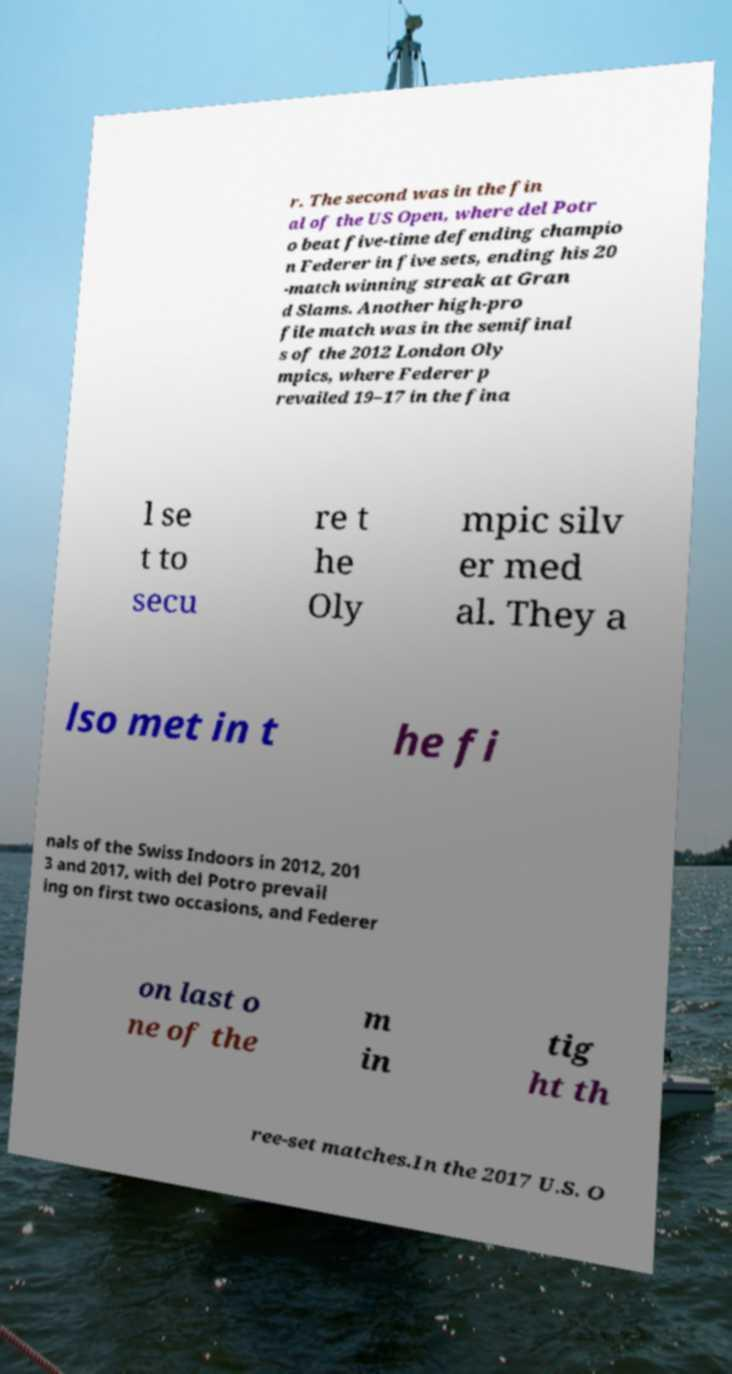There's text embedded in this image that I need extracted. Can you transcribe it verbatim? r. The second was in the fin al of the US Open, where del Potr o beat five-time defending champio n Federer in five sets, ending his 20 -match winning streak at Gran d Slams. Another high-pro file match was in the semifinal s of the 2012 London Oly mpics, where Federer p revailed 19–17 in the fina l se t to secu re t he Oly mpic silv er med al. They a lso met in t he fi nals of the Swiss Indoors in 2012, 201 3 and 2017, with del Potro prevail ing on first two occasions, and Federer on last o ne of the m in tig ht th ree-set matches.In the 2017 U.S. O 